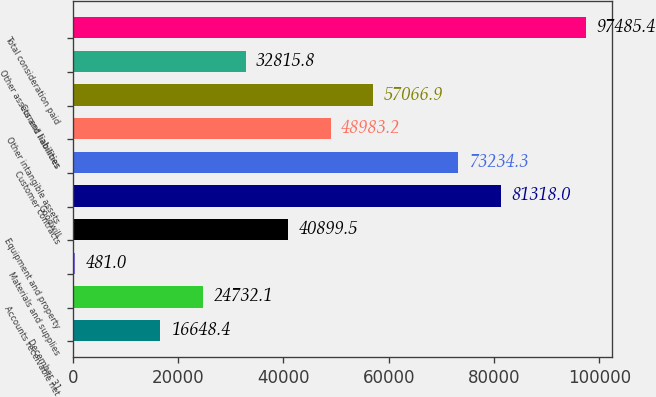<chart> <loc_0><loc_0><loc_500><loc_500><bar_chart><fcel>December 31<fcel>Accounts receivable net<fcel>Materials and supplies<fcel>Equipment and property<fcel>Goodwill<fcel>Customer contracts<fcel>Other intangible assets<fcel>Current liabilities<fcel>Other assets and liabilities<fcel>Total consideration paid<nl><fcel>16648.4<fcel>24732.1<fcel>481<fcel>40899.5<fcel>81318<fcel>73234.3<fcel>48983.2<fcel>57066.9<fcel>32815.8<fcel>97485.4<nl></chart> 